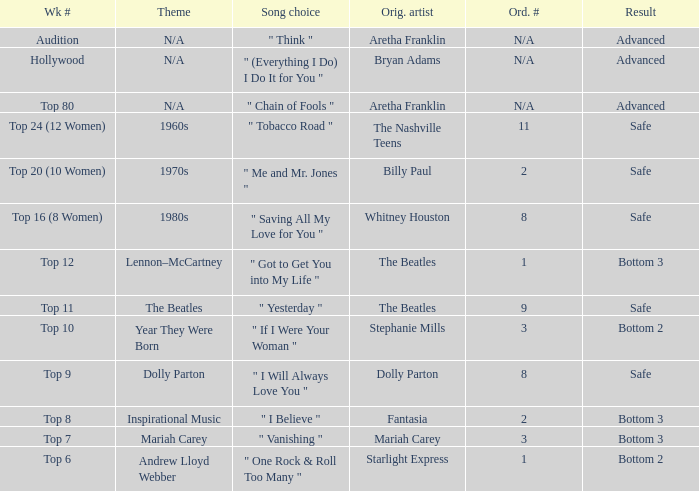Name the order number for the beatles and result is safe 9.0. 